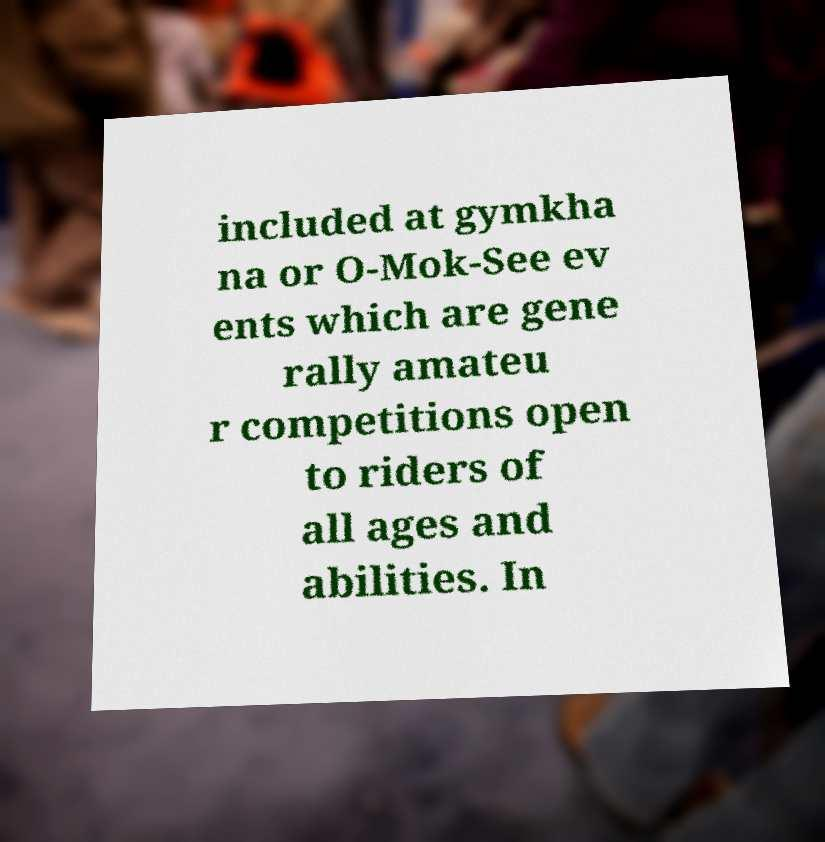Can you accurately transcribe the text from the provided image for me? included at gymkha na or O-Mok-See ev ents which are gene rally amateu r competitions open to riders of all ages and abilities. In 